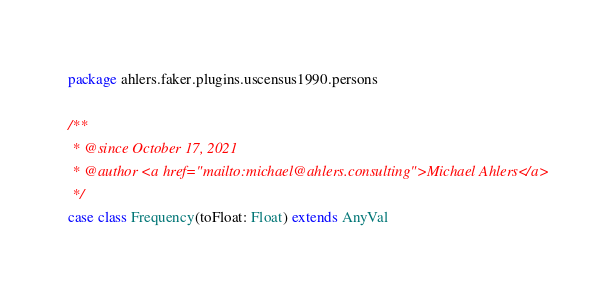<code> <loc_0><loc_0><loc_500><loc_500><_Scala_>package ahlers.faker.plugins.uscensus1990.persons

/**
 * @since October 17, 2021
 * @author <a href="mailto:michael@ahlers.consulting">Michael Ahlers</a>
 */
case class Frequency(toFloat: Float) extends AnyVal
</code> 